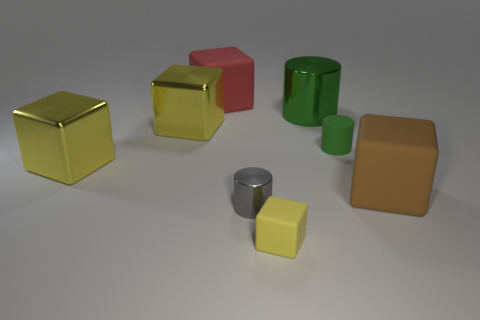Add 1 brown rubber balls. How many objects exist? 9 Subtract all big shiny cylinders. How many cylinders are left? 2 Subtract all cyan cylinders. How many yellow cubes are left? 3 Subtract all brown blocks. How many blocks are left? 4 Add 8 red matte blocks. How many red matte blocks are left? 9 Add 3 large metal objects. How many large metal objects exist? 6 Subtract 0 purple cylinders. How many objects are left? 8 Subtract all cylinders. How many objects are left? 5 Subtract 4 cubes. How many cubes are left? 1 Subtract all yellow cylinders. Subtract all cyan spheres. How many cylinders are left? 3 